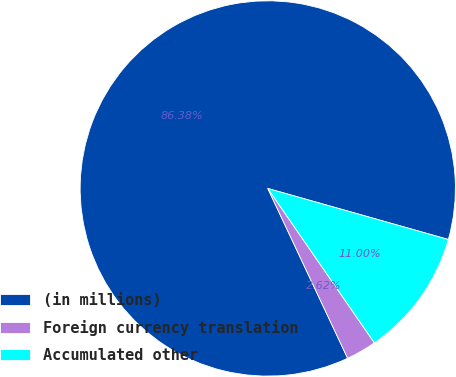Convert chart to OTSL. <chart><loc_0><loc_0><loc_500><loc_500><pie_chart><fcel>(in millions)<fcel>Foreign currency translation<fcel>Accumulated other<nl><fcel>86.38%<fcel>2.62%<fcel>11.0%<nl></chart> 